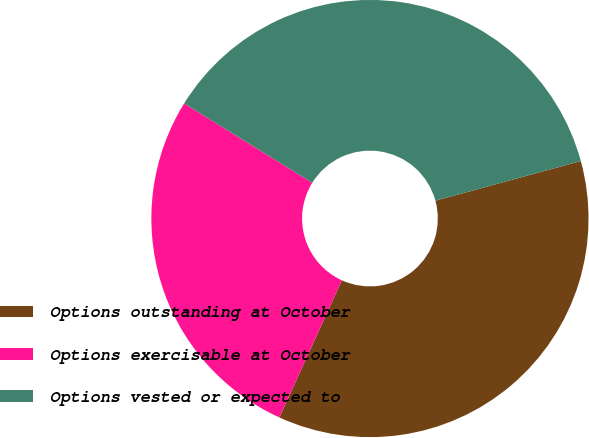<chart> <loc_0><loc_0><loc_500><loc_500><pie_chart><fcel>Options outstanding at October<fcel>Options exercisable at October<fcel>Options vested or expected to<nl><fcel>36.04%<fcel>27.03%<fcel>36.94%<nl></chart> 